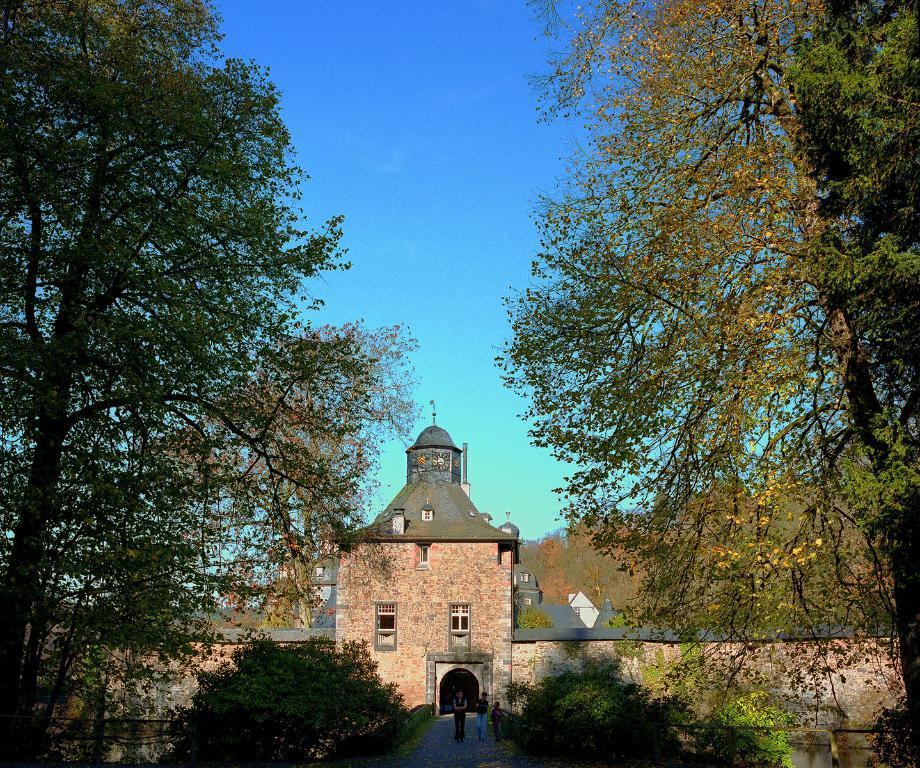What type of vegetation can be seen in the image? There are trees in the image. What is happening in the center of the image? There are people standing in the center of the image. What can be seen in the background of the image? There is a building visible in the background, and the sky is also visible. How many geese are present in the image? There are no geese present in the image. What type of things are the people holding in the image? The provided facts do not mention any specific things that the people are holding in the image. 